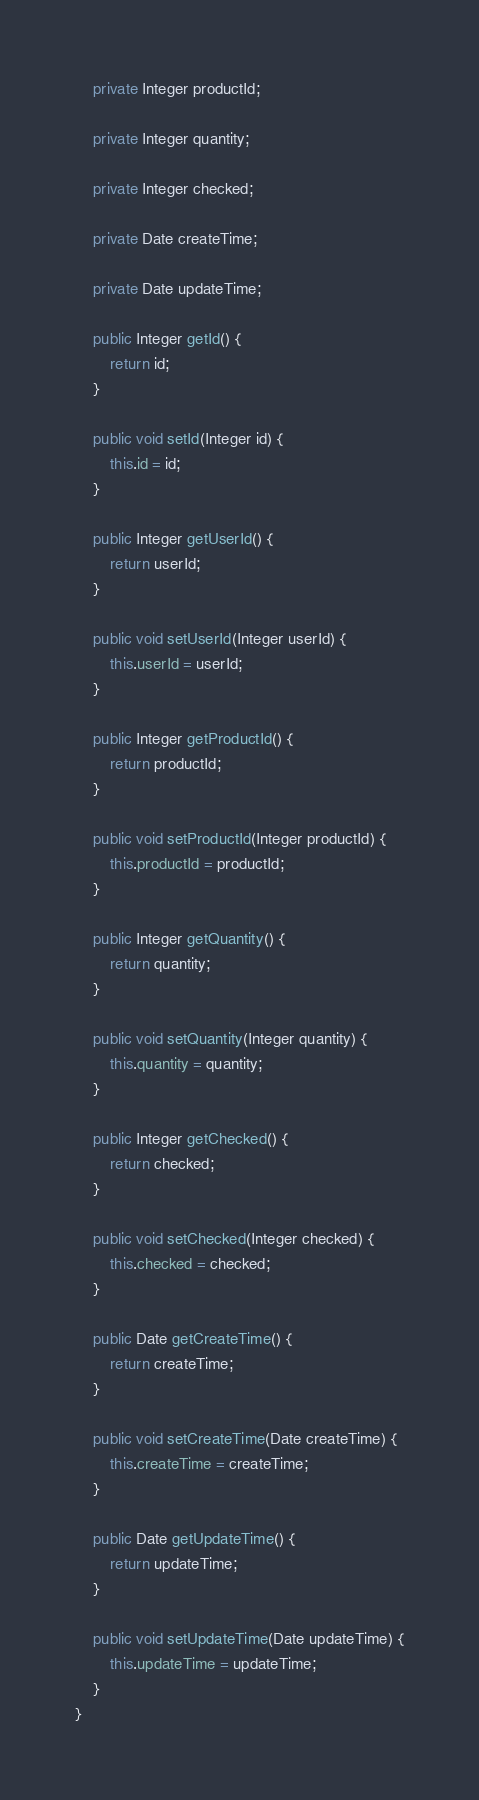<code> <loc_0><loc_0><loc_500><loc_500><_Java_>    private Integer productId;

    private Integer quantity;

    private Integer checked;

    private Date createTime;

    private Date updateTime;

    public Integer getId() {
        return id;
    }

    public void setId(Integer id) {
        this.id = id;
    }

    public Integer getUserId() {
        return userId;
    }

    public void setUserId(Integer userId) {
        this.userId = userId;
    }

    public Integer getProductId() {
        return productId;
    }

    public void setProductId(Integer productId) {
        this.productId = productId;
    }

    public Integer getQuantity() {
        return quantity;
    }

    public void setQuantity(Integer quantity) {
        this.quantity = quantity;
    }

    public Integer getChecked() {
        return checked;
    }

    public void setChecked(Integer checked) {
        this.checked = checked;
    }

    public Date getCreateTime() {
        return createTime;
    }

    public void setCreateTime(Date createTime) {
        this.createTime = createTime;
    }

    public Date getUpdateTime() {
        return updateTime;
    }

    public void setUpdateTime(Date updateTime) {
        this.updateTime = updateTime;
    }
}</code> 